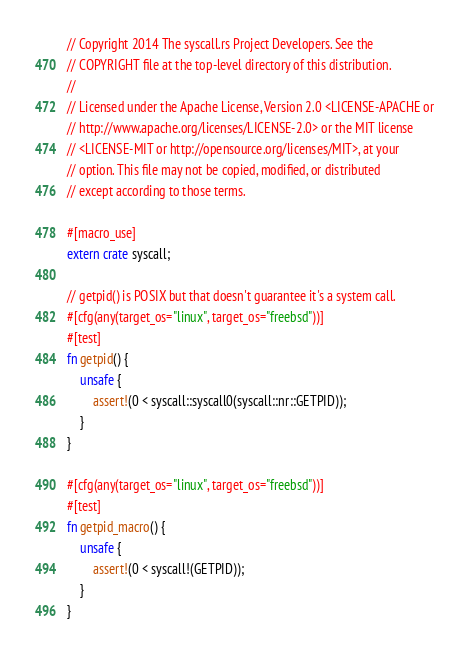<code> <loc_0><loc_0><loc_500><loc_500><_Rust_>// Copyright 2014 The syscall.rs Project Developers. See the
// COPYRIGHT file at the top-level directory of this distribution.
//
// Licensed under the Apache License, Version 2.0 <LICENSE-APACHE or
// http://www.apache.org/licenses/LICENSE-2.0> or the MIT license
// <LICENSE-MIT or http://opensource.org/licenses/MIT>, at your
// option. This file may not be copied, modified, or distributed
// except according to those terms.

#[macro_use]
extern crate syscall;

// getpid() is POSIX but that doesn't guarantee it's a system call.
#[cfg(any(target_os="linux", target_os="freebsd"))]
#[test]
fn getpid() {
    unsafe {
        assert!(0 < syscall::syscall0(syscall::nr::GETPID));
    }
}

#[cfg(any(target_os="linux", target_os="freebsd"))]
#[test]
fn getpid_macro() {
    unsafe {
        assert!(0 < syscall!(GETPID));
    }
}
</code> 